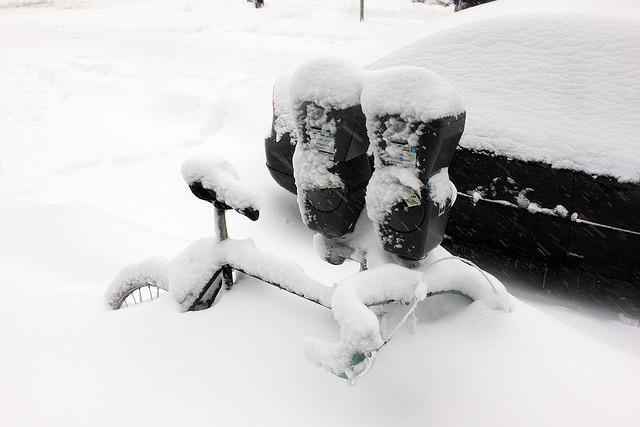How many meters are there?
Give a very brief answer. 2. How many parking meters can you see?
Give a very brief answer. 2. 